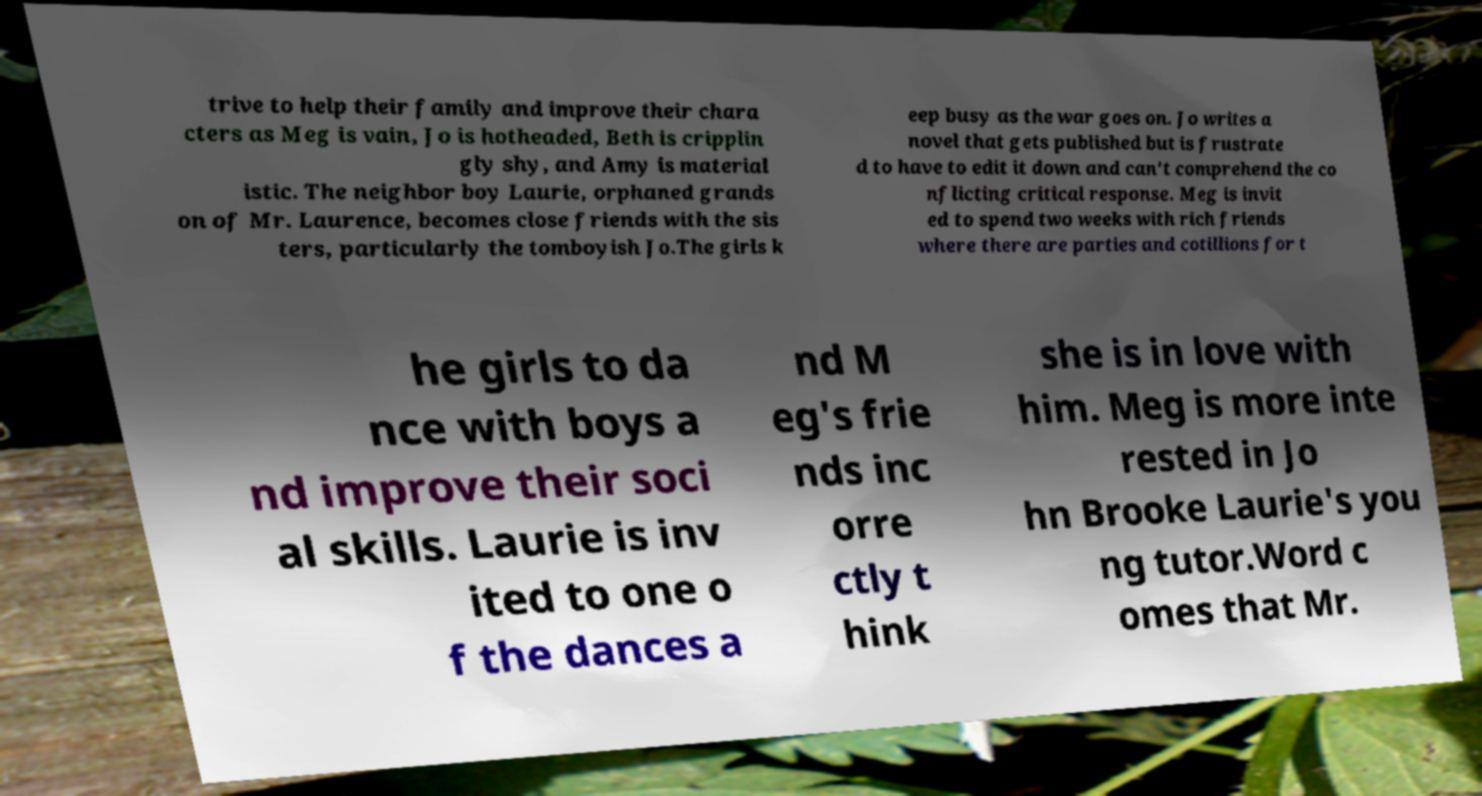Please identify and transcribe the text found in this image. trive to help their family and improve their chara cters as Meg is vain, Jo is hotheaded, Beth is cripplin gly shy, and Amy is material istic. The neighbor boy Laurie, orphaned grands on of Mr. Laurence, becomes close friends with the sis ters, particularly the tomboyish Jo.The girls k eep busy as the war goes on. Jo writes a novel that gets published but is frustrate d to have to edit it down and can't comprehend the co nflicting critical response. Meg is invit ed to spend two weeks with rich friends where there are parties and cotillions for t he girls to da nce with boys a nd improve their soci al skills. Laurie is inv ited to one o f the dances a nd M eg's frie nds inc orre ctly t hink she is in love with him. Meg is more inte rested in Jo hn Brooke Laurie's you ng tutor.Word c omes that Mr. 